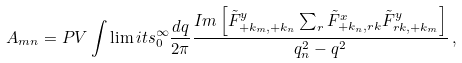<formula> <loc_0><loc_0><loc_500><loc_500>A _ { m n } = P V \int \lim i t s _ { 0 } ^ { \infty } \frac { d q } { 2 \pi } \frac { I m \left [ \tilde { F } ^ { y } _ { + k _ { m } , + k _ { n } } \sum _ { r } \tilde { F } ^ { x } _ { + k _ { n } , r k } \tilde { F } ^ { y } _ { r k , + k _ { m } } \right ] } { q ^ { 2 } _ { n } - q ^ { 2 } } \, ,</formula> 